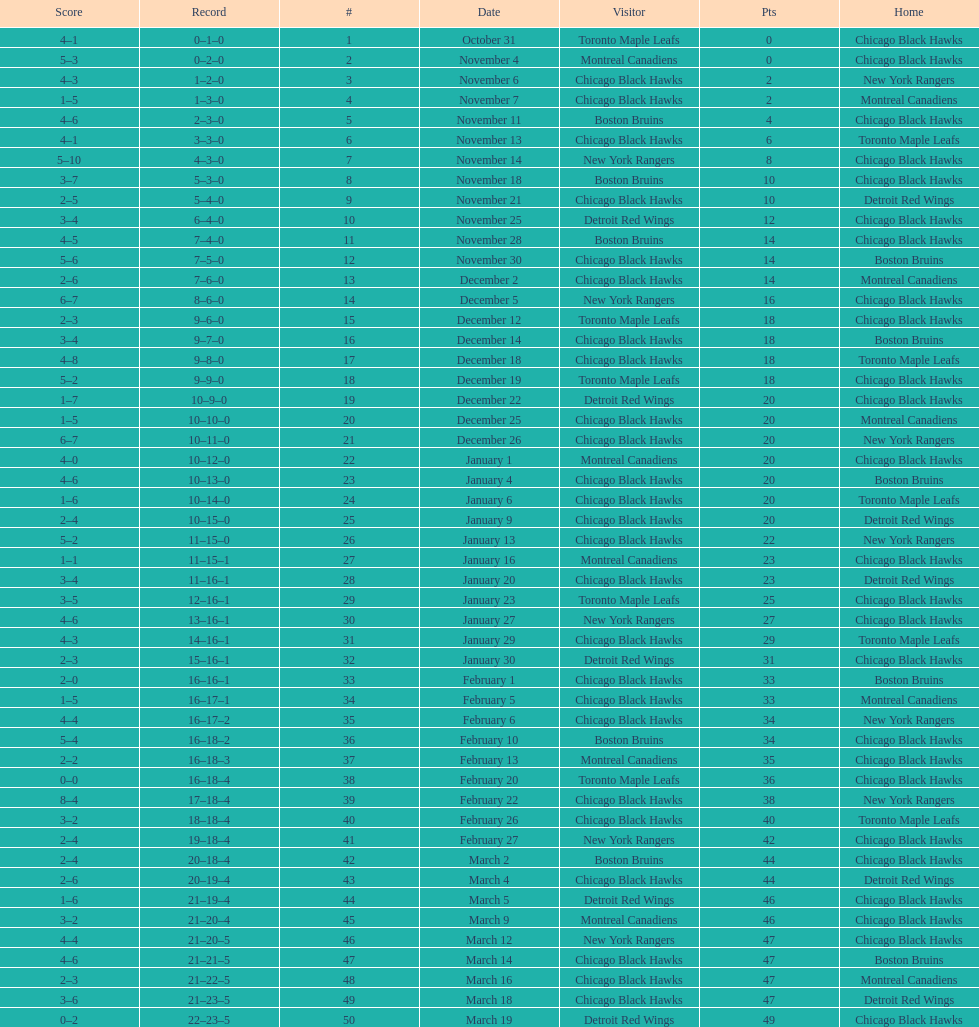What was the total amount of points scored on november 4th? 8. 